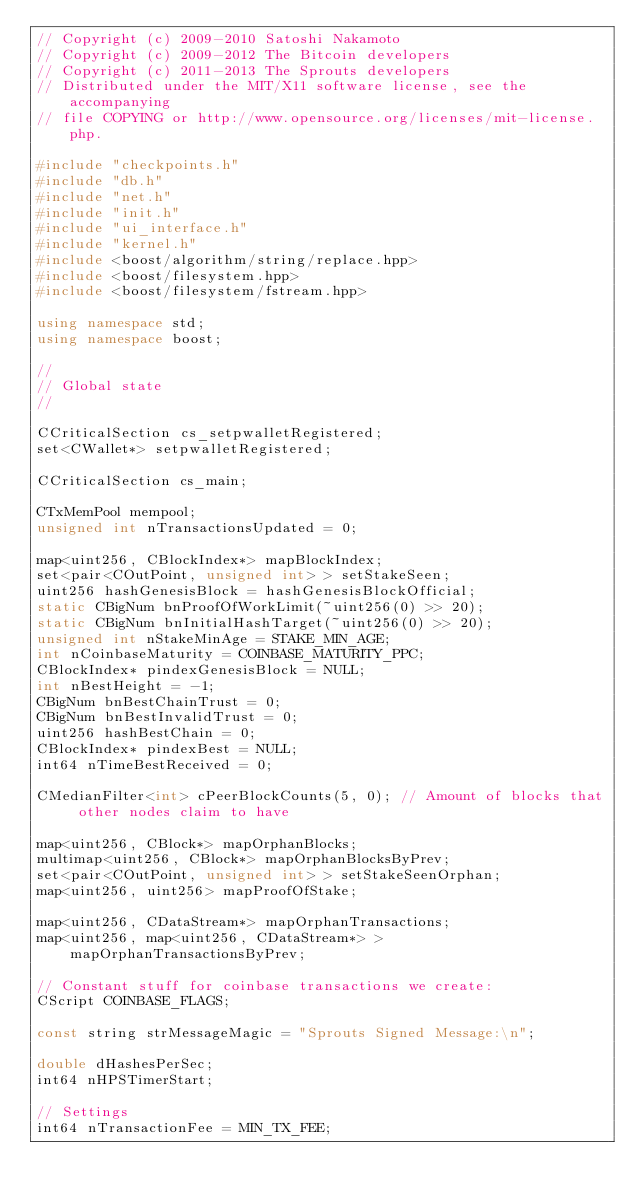Convert code to text. <code><loc_0><loc_0><loc_500><loc_500><_C++_>// Copyright (c) 2009-2010 Satoshi Nakamoto
// Copyright (c) 2009-2012 The Bitcoin developers
// Copyright (c) 2011-2013 The Sprouts developers
// Distributed under the MIT/X11 software license, see the accompanying
// file COPYING or http://www.opensource.org/licenses/mit-license.php.

#include "checkpoints.h"
#include "db.h"
#include "net.h"
#include "init.h"
#include "ui_interface.h"
#include "kernel.h"
#include <boost/algorithm/string/replace.hpp>
#include <boost/filesystem.hpp>
#include <boost/filesystem/fstream.hpp>

using namespace std;
using namespace boost;

//
// Global state
//

CCriticalSection cs_setpwalletRegistered;
set<CWallet*> setpwalletRegistered;

CCriticalSection cs_main;

CTxMemPool mempool;
unsigned int nTransactionsUpdated = 0;

map<uint256, CBlockIndex*> mapBlockIndex;
set<pair<COutPoint, unsigned int> > setStakeSeen;
uint256 hashGenesisBlock = hashGenesisBlockOfficial;
static CBigNum bnProofOfWorkLimit(~uint256(0) >> 20);
static CBigNum bnInitialHashTarget(~uint256(0) >> 20);
unsigned int nStakeMinAge = STAKE_MIN_AGE;
int nCoinbaseMaturity = COINBASE_MATURITY_PPC;
CBlockIndex* pindexGenesisBlock = NULL;
int nBestHeight = -1;
CBigNum bnBestChainTrust = 0;
CBigNum bnBestInvalidTrust = 0;
uint256 hashBestChain = 0;
CBlockIndex* pindexBest = NULL;
int64 nTimeBestReceived = 0;

CMedianFilter<int> cPeerBlockCounts(5, 0); // Amount of blocks that other nodes claim to have

map<uint256, CBlock*> mapOrphanBlocks;
multimap<uint256, CBlock*> mapOrphanBlocksByPrev;
set<pair<COutPoint, unsigned int> > setStakeSeenOrphan;
map<uint256, uint256> mapProofOfStake;

map<uint256, CDataStream*> mapOrphanTransactions;
map<uint256, map<uint256, CDataStream*> > mapOrphanTransactionsByPrev;

// Constant stuff for coinbase transactions we create:
CScript COINBASE_FLAGS;

const string strMessageMagic = "Sprouts Signed Message:\n";

double dHashesPerSec;
int64 nHPSTimerStart;

// Settings
int64 nTransactionFee = MIN_TX_FEE;


</code> 